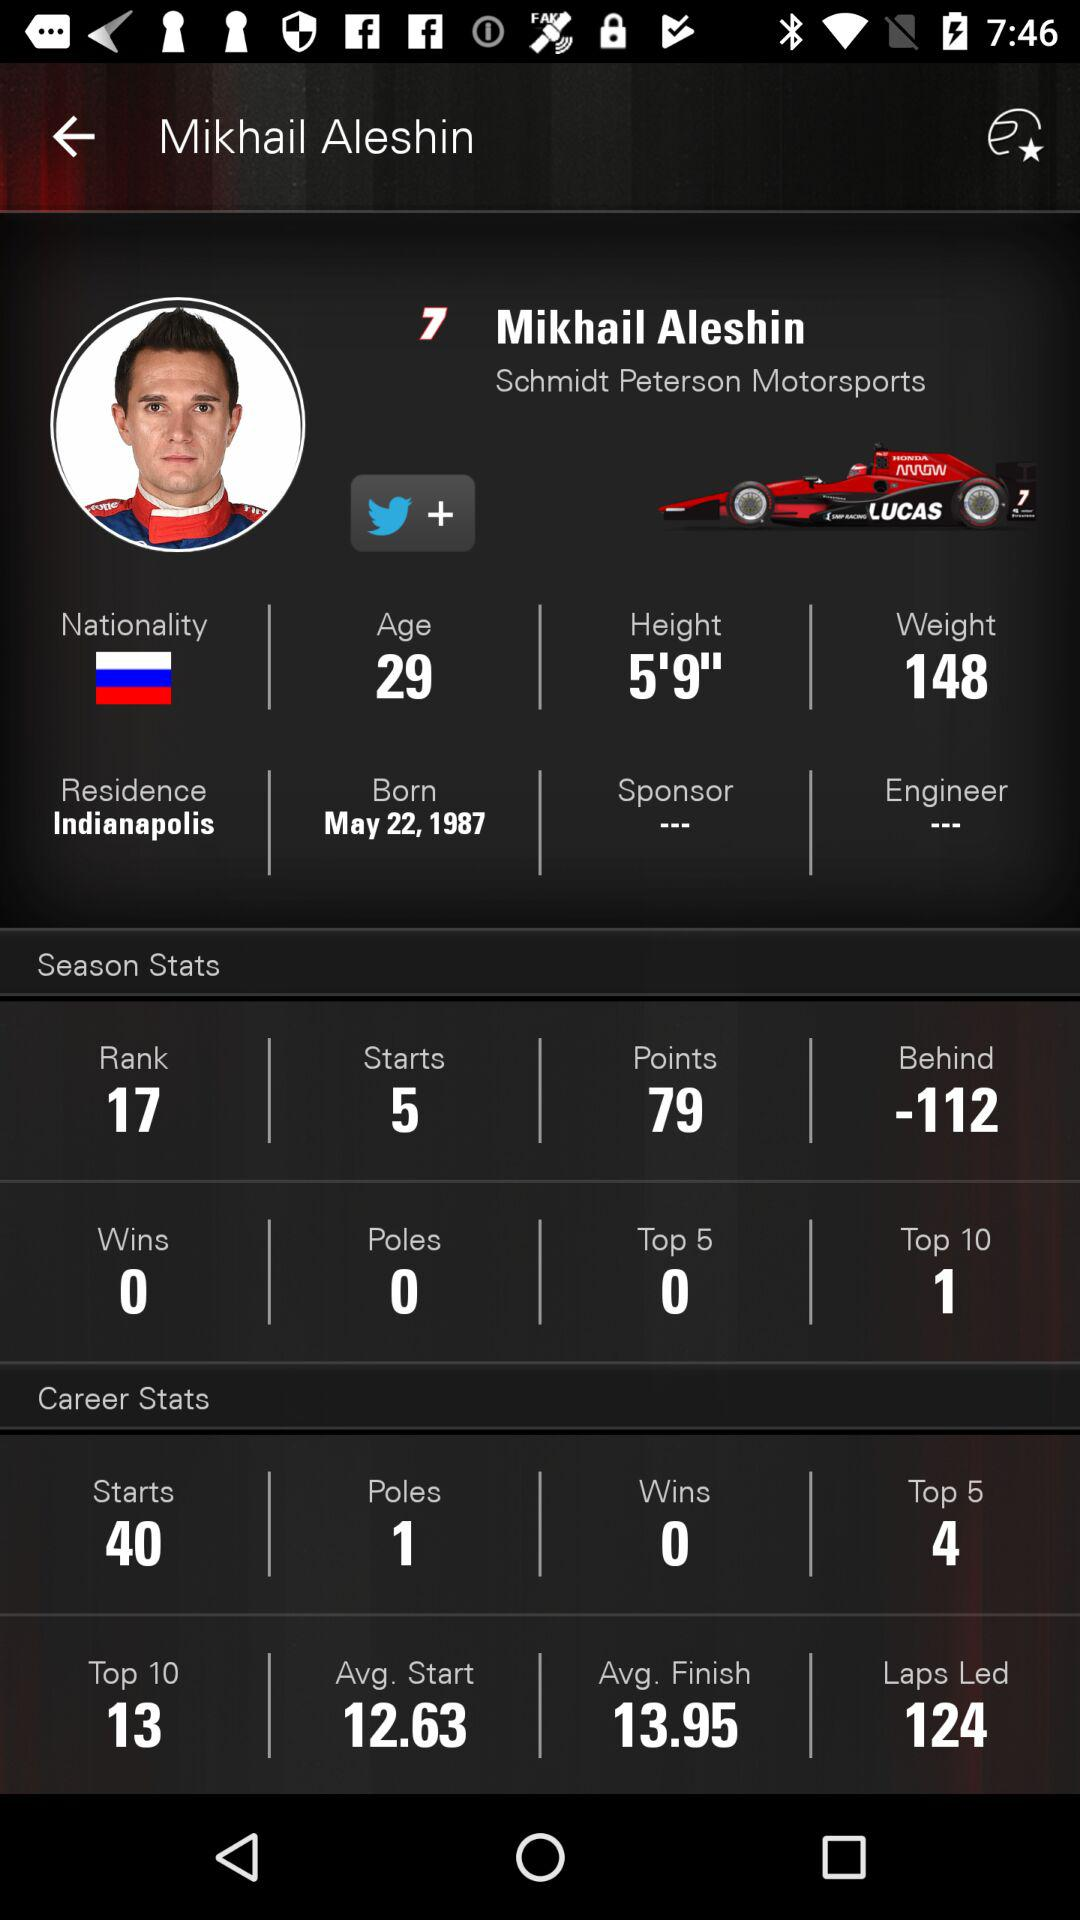What is the weight of Mikhail Aleshin? Mikhail Aleshin weighs 148. 